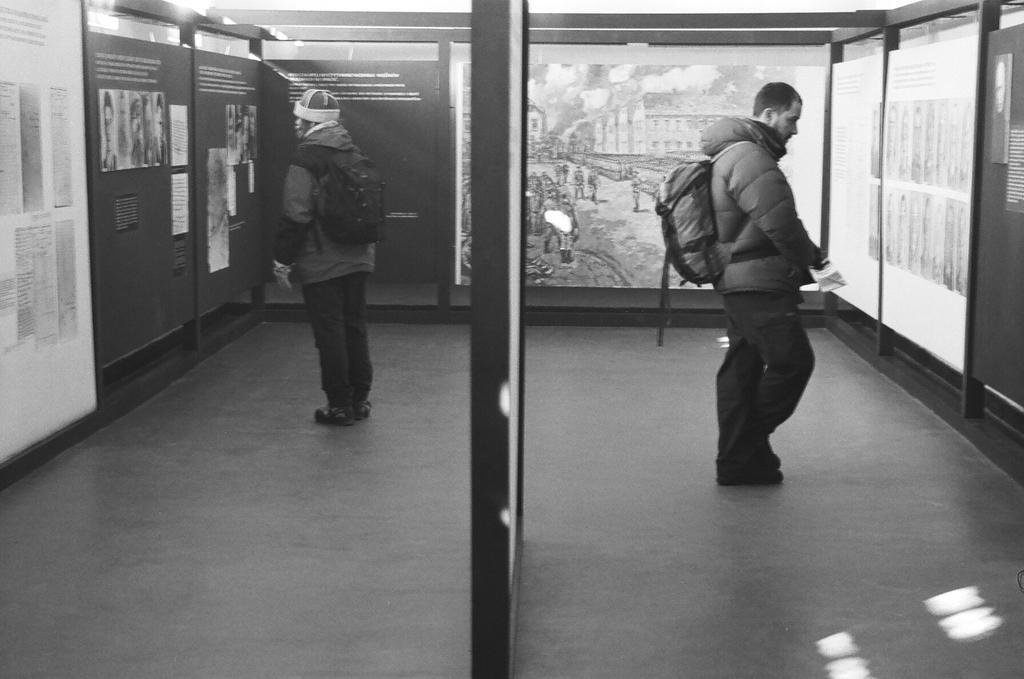Can you describe this image briefly? In this image I can see two persons are standing and I can see both of them are wearing jackets, pants and both of them are carrying bags. I can also see one of them is wearing a cap. I can also see number of posters, few boards and on these boards I can see something is written. I can also see this image is black and white in colour. 